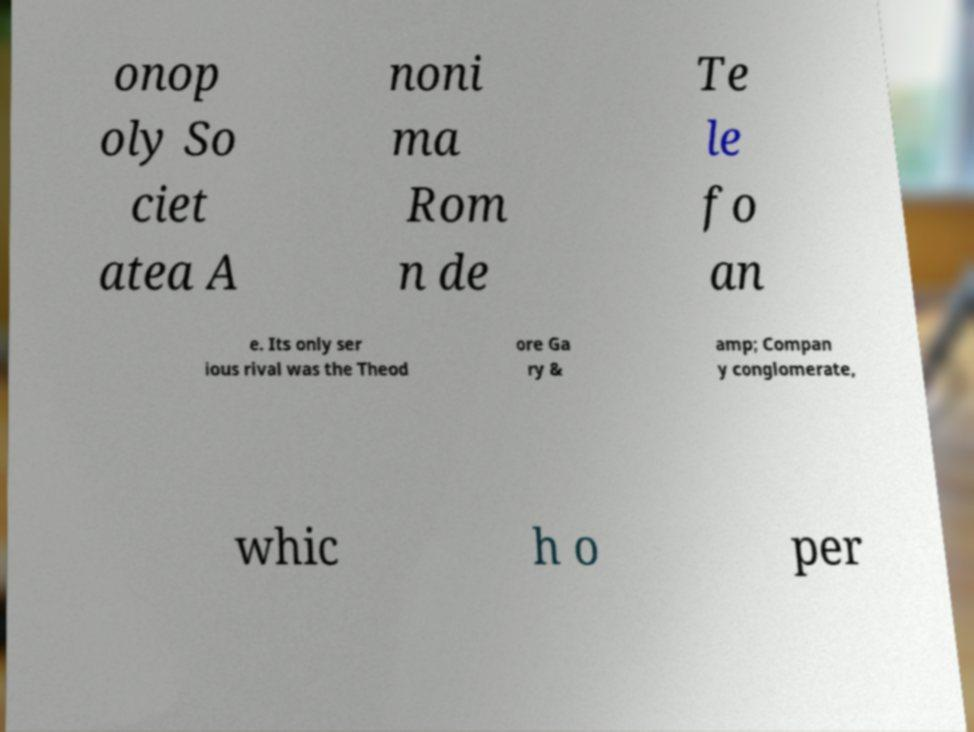I need the written content from this picture converted into text. Can you do that? onop oly So ciet atea A noni ma Rom n de Te le fo an e. Its only ser ious rival was the Theod ore Ga ry & amp; Compan y conglomerate, whic h o per 